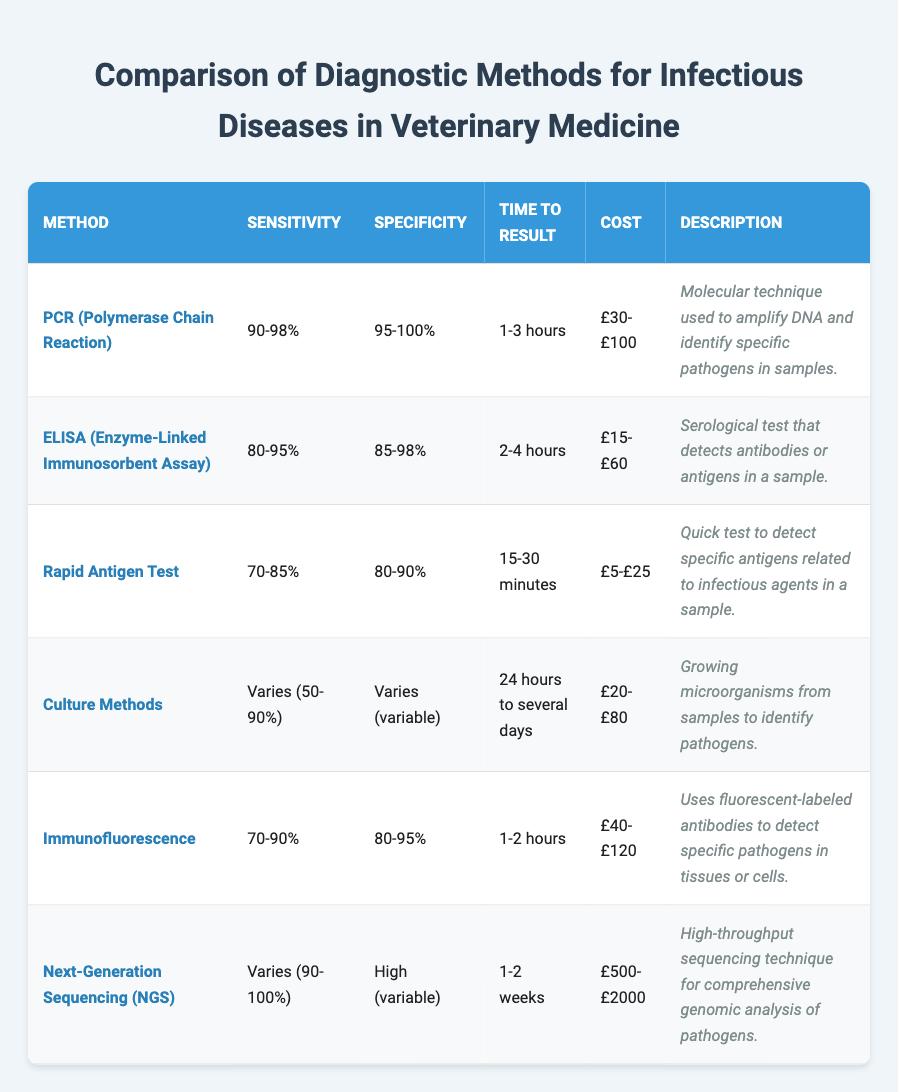What is the method with the highest sensitivity? The highest sensitivity in the table is listed under PCR (Polymerase Chain Reaction) with a range of 90-98%.
Answer: PCR (Polymerase Chain Reaction) Which diagnostic method has the quickest time to result? The Rapid Antigen Test has the quickest time to result, taking only 15-30 minutes.
Answer: Rapid Antigen Test What is the cost range for ELISA? The cost range for ELISA is £15-£60, as stated in the table.
Answer: £15-£60 How does the sensitivity of Immunofluorescence compare to that of Culture Methods? The sensitivity of Immunofluorescence ranges from 70-90%, while the sensitivity of Culture Methods is variable, ranging from 50-90%. Since the lower bound of Immunofluorescence (70%) is higher than the lower bound of Culture Methods (50%), it has a generally better lower sensitivity.
Answer: Immunofluorescence has generally better sensitivity than Culture Methods Is the cost of Next-Generation Sequencing (NGS) higher than that of PCR? The cost of NGS ranges from £500-£2000, while PCR ranges from £30-£100. Since £500 is greater than the highest cost of PCR (£100), NGS is indeed more expensive.
Answer: Yes Calculate the average sensitivity range of all methods listed. To calculate the average sensitivity range, we take the middle values of the sensitivity ranges where applicable. PCR: 94%, ELISA: 87.5%, Rapid Antigen Test: 77.5%, Culture Methods: 70%, Immunofluorescence: 80%, NGS: 95%. Adding these up gives us 94 + 87.5 + 77.5 + 70 + 80 + 95 = 504. There are 6 methods, so the average is 504/6 = 84%.
Answer: 84% What is the specificity range of the Rapid Antigen Test? The specificity range for the Rapid Antigen Test is listed as 80-90% in the table.
Answer: 80-90% Which method has the highest cost and what is it? Next-Generation Sequencing (NGS) has the highest cost range, which is £500-£2000.
Answer: Next-Generation Sequencing (NGS), £500-£2000 Is the sensitivity of ELISA lower than that of PCR? ELISA has a sensitivity range of 80-95%, while PCR has a sensitivity range of 90-98%. Since the lower bound of ELISA (80%) is less than PCR's lower bound (90%), ELISA's sensitivity is lower.
Answer: Yes What diagnostic method requires a longer time to result than Next-Generation Sequencing (NGS)? The only method that requires a longer time to result is Culture Methods, which takes 24 hours to several days, while NGS takes 1-2 weeks. Since 1-2 weeks is longer than several days, Culture Methods take longer.
Answer: Culture Methods 